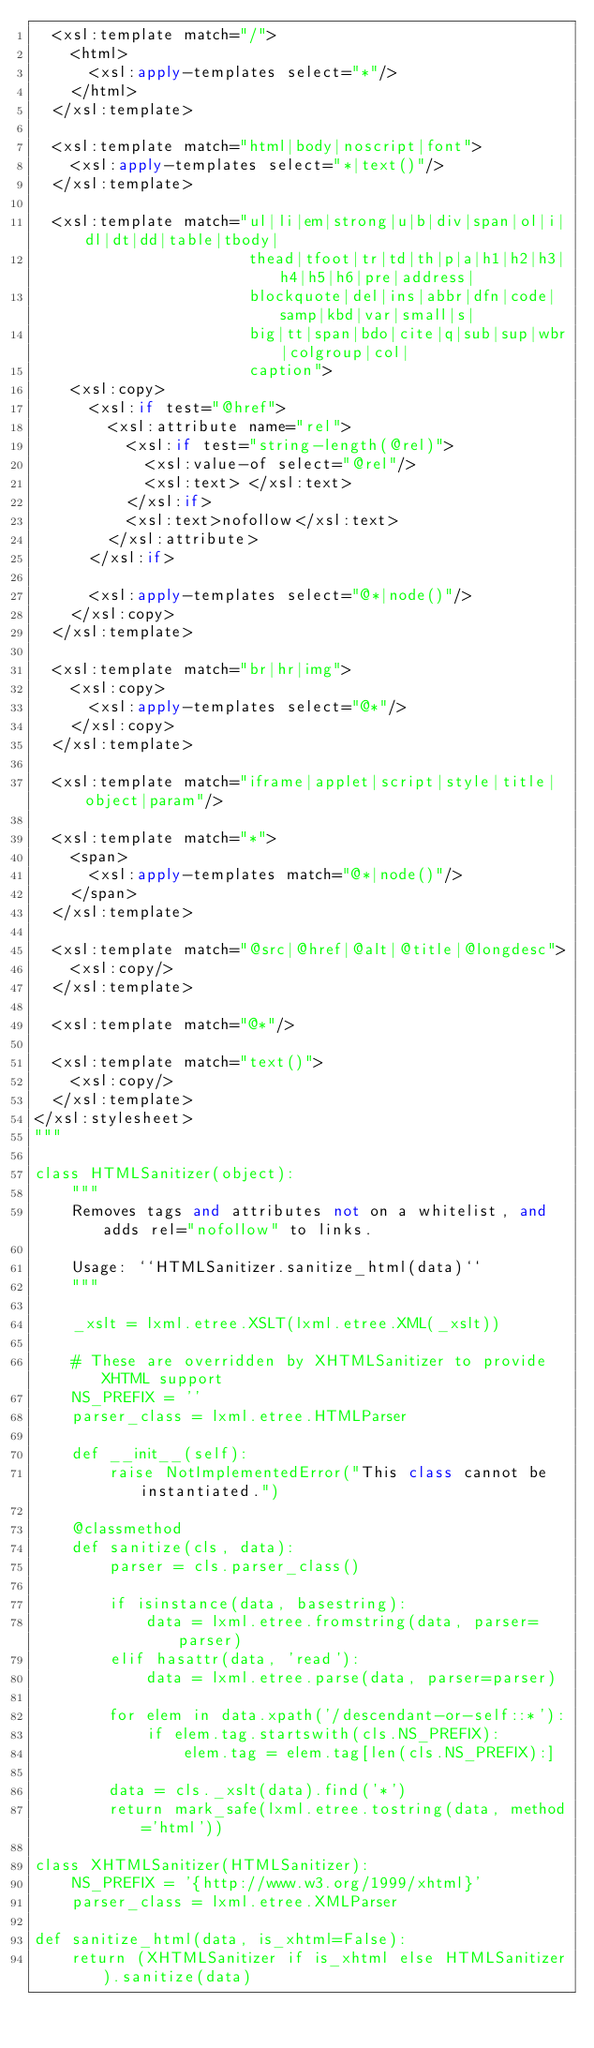<code> <loc_0><loc_0><loc_500><loc_500><_Python_>  <xsl:template match="/">
    <html>
      <xsl:apply-templates select="*"/>
    </html>
  </xsl:template>

  <xsl:template match="html|body|noscript|font">
    <xsl:apply-templates select="*|text()"/>
  </xsl:template>

  <xsl:template match="ul|li|em|strong|u|b|div|span|ol|i|dl|dt|dd|table|tbody|
                       thead|tfoot|tr|td|th|p|a|h1|h2|h3|h4|h5|h6|pre|address|
                       blockquote|del|ins|abbr|dfn|code|samp|kbd|var|small|s|
                       big|tt|span|bdo|cite|q|sub|sup|wbr|colgroup|col|
                       caption">
    <xsl:copy>
      <xsl:if test="@href">
        <xsl:attribute name="rel">
          <xsl:if test="string-length(@rel)">
            <xsl:value-of select="@rel"/>
            <xsl:text> </xsl:text>
          </xsl:if>
          <xsl:text>nofollow</xsl:text>
        </xsl:attribute>
      </xsl:if>

      <xsl:apply-templates select="@*|node()"/>
    </xsl:copy>
  </xsl:template>

  <xsl:template match="br|hr|img">
    <xsl:copy>
      <xsl:apply-templates select="@*"/>
    </xsl:copy>
  </xsl:template>

  <xsl:template match="iframe|applet|script|style|title|object|param"/>

  <xsl:template match="*">
    <span>
      <xsl:apply-templates match="@*|node()"/>
    </span>
  </xsl:template>

  <xsl:template match="@src|@href|@alt|@title|@longdesc">
    <xsl:copy/>
  </xsl:template>

  <xsl:template match="@*"/>

  <xsl:template match="text()">
    <xsl:copy/>
  </xsl:template>
</xsl:stylesheet>
"""

class HTMLSanitizer(object):
    """
    Removes tags and attributes not on a whitelist, and adds rel="nofollow" to links.

    Usage: ``HTMLSanitizer.sanitize_html(data)``
    """

    _xslt = lxml.etree.XSLT(lxml.etree.XML(_xslt))

    # These are overridden by XHTMLSanitizer to provide XHTML support
    NS_PREFIX = ''
    parser_class = lxml.etree.HTMLParser

    def __init__(self):
        raise NotImplementedError("This class cannot be instantiated.")

    @classmethod
    def sanitize(cls, data):
        parser = cls.parser_class()

        if isinstance(data, basestring):
            data = lxml.etree.fromstring(data, parser=parser)
        elif hasattr(data, 'read'):
            data = lxml.etree.parse(data, parser=parser)

        for elem in data.xpath('/descendant-or-self::*'):
            if elem.tag.startswith(cls.NS_PREFIX):
                elem.tag = elem.tag[len(cls.NS_PREFIX):]

        data = cls._xslt(data).find('*')
        return mark_safe(lxml.etree.tostring(data, method='html'))

class XHTMLSanitizer(HTMLSanitizer):
    NS_PREFIX = '{http://www.w3.org/1999/xhtml}'
    parser_class = lxml.etree.XMLParser

def sanitize_html(data, is_xhtml=False):
    return (XHTMLSanitizer if is_xhtml else HTMLSanitizer).sanitize(data)
</code> 